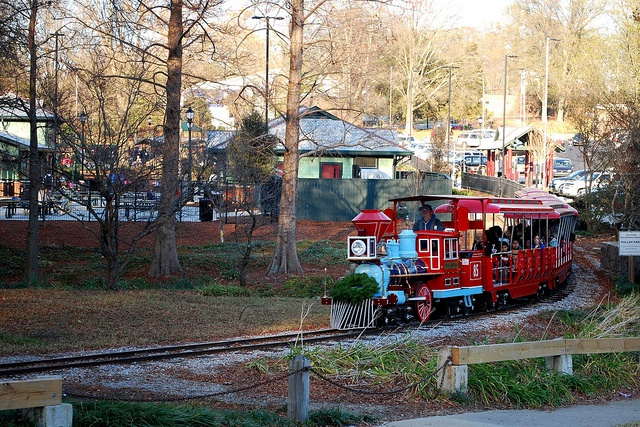Describe the objects in this image and their specific colors. I can see train in gray, black, and maroon tones, car in gray, white, darkgray, and lightblue tones, people in gray, black, navy, and maroon tones, car in gray, white, darkgray, and tan tones, and car in gray, lightgray, darkgray, and lightblue tones in this image. 